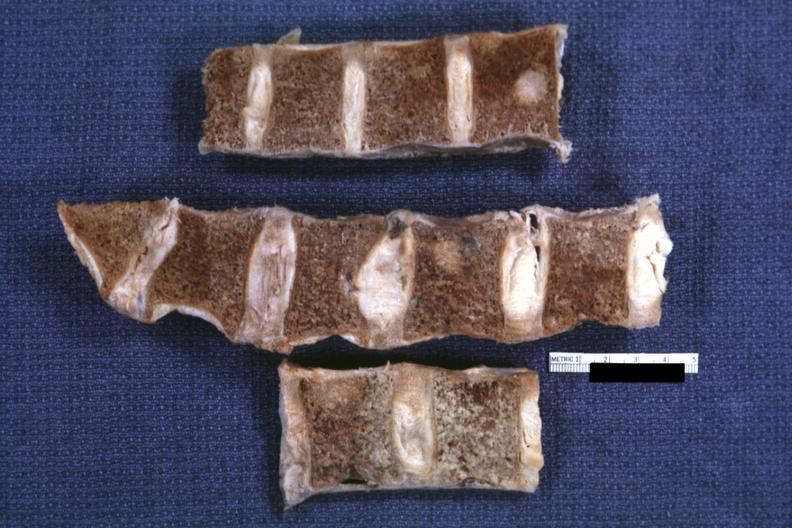s joints present?
Answer the question using a single word or phrase. Yes 